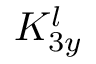Convert formula to latex. <formula><loc_0><loc_0><loc_500><loc_500>K _ { 3 y } ^ { l }</formula> 